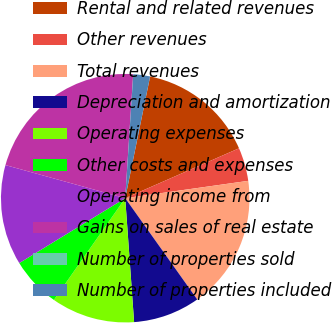<chart> <loc_0><loc_0><loc_500><loc_500><pie_chart><fcel>Rental and related revenues<fcel>Other revenues<fcel>Total revenues<fcel>Depreciation and amortization<fcel>Operating expenses<fcel>Other costs and expenses<fcel>Operating income from<fcel>Gains on sales of real estate<fcel>Number of properties sold<fcel>Number of properties included<nl><fcel>15.21%<fcel>4.35%<fcel>17.39%<fcel>8.7%<fcel>10.87%<fcel>6.52%<fcel>13.04%<fcel>21.73%<fcel>0.01%<fcel>2.18%<nl></chart> 